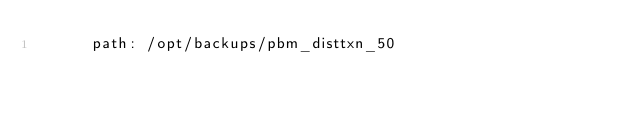Convert code to text. <code><loc_0><loc_0><loc_500><loc_500><_YAML_>      path: /opt/backups/pbm_disttxn_50
  
</code> 